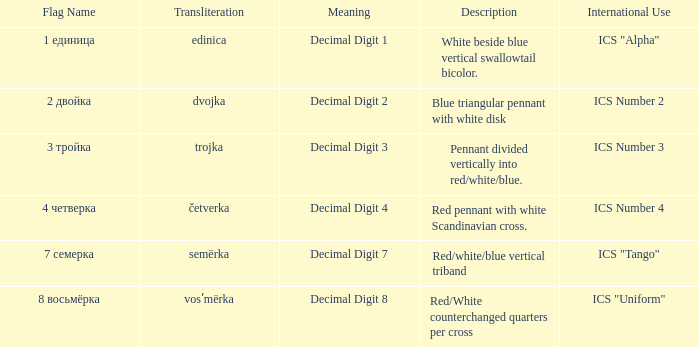What are the denotations of the flag with a name that is converted to semërka? Decimal Digit 7. 